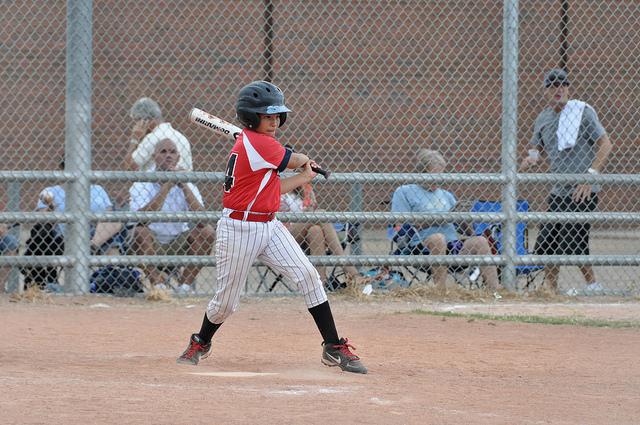Is this a professional baseball player?
Short answer required. No. Did the batter hit the ball?
Give a very brief answer. Yes. Are the spectators cheering?
Answer briefly. No. 